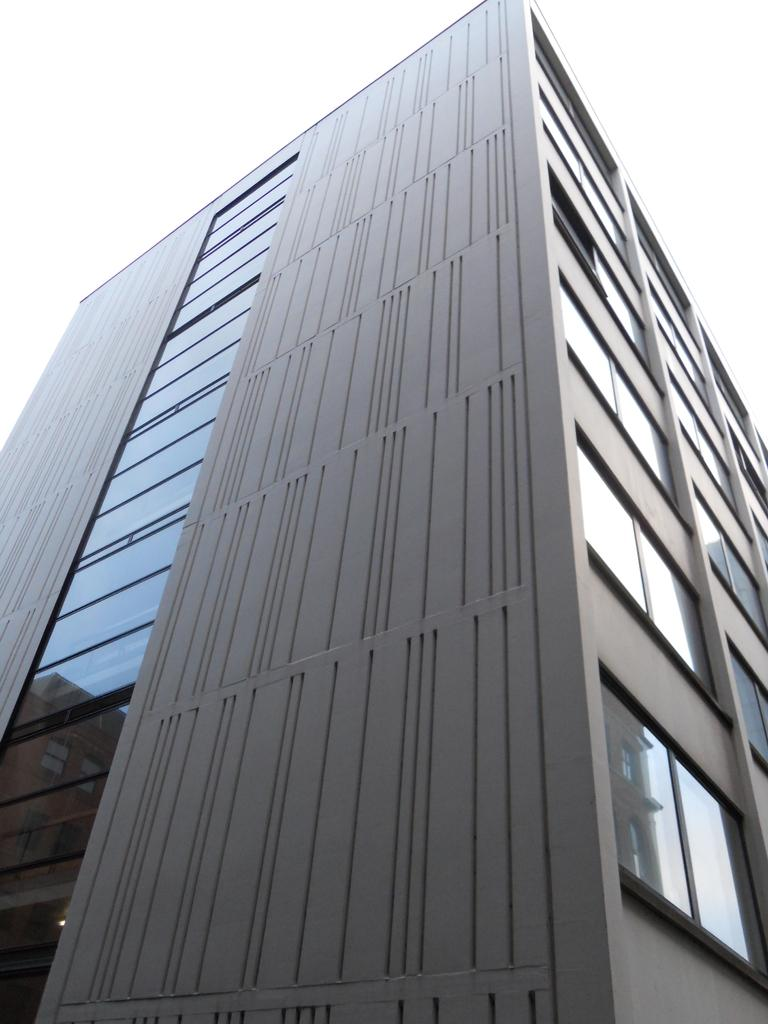What is the main subject in the foreground of the image? There is a building in front of the image. What can be seen in the background of the image? The sky is visible in the background of the image. What type of disgusting silver tax can be seen in the image? There is no silver tax or any tax-related object present in the image. 